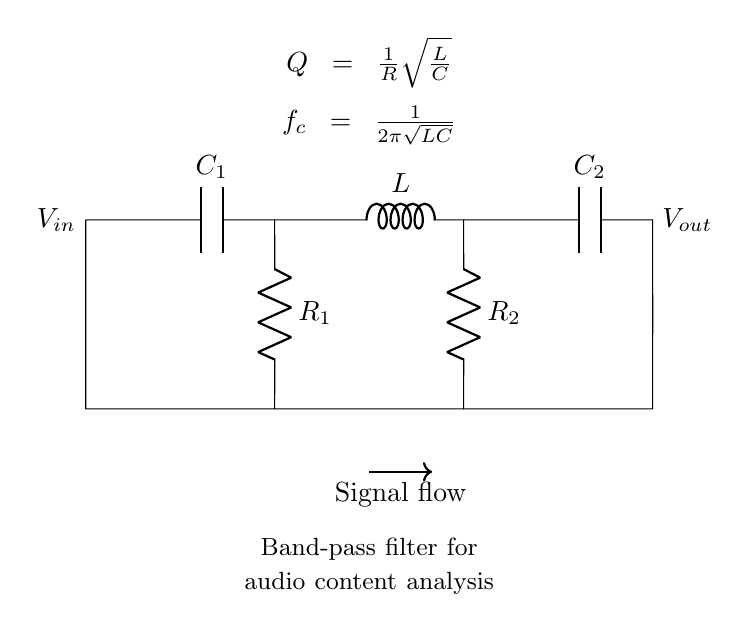What are the components in this circuit? The circuit contains two capacitors (C1 and C2), an inductor (L), and two resistors (R1 and R2). These components are clearly labeled in the diagram.
Answer: C1, C2, L, R1, R2 What is the function of this circuit? This circuit functions as a band-pass filter, which isolates specific frequency ranges from an input signal. The label in the diagram indicates its purpose directly.
Answer: Band-pass filter What is the formula for the cutoff frequency (f_c) in this circuit? The formula for cutoff frequency is given in the diagram and is calculated using the components L and C. It is noted as f_c = 1/(2π√(LC)).
Answer: 1/(2π√(LC)) How does the quality factor (Q) relate to the resistors in this circuit? The quality factor is represented by the formula Q = 1/R√(L/C) in the diagram. It indicates the circuit's selectivity and is inversely related to the resistance.
Answer: 1/R√(L/C) Which component limits high-frequency signals? The capacitor C2 primarily serves to block DC and limit high-frequency signals from passing through the filter by offering short-circuit to those frequencies.
Answer: C2 How does the presence of R1 affect the circuit's behavior? R1's value directly influences the circuit's quality factor (Q). A lower resistance increases Q, leading to a sharper filter response, as indicated by the formula Q = 1/R√(L/C).
Answer: Q increases with lower R1 